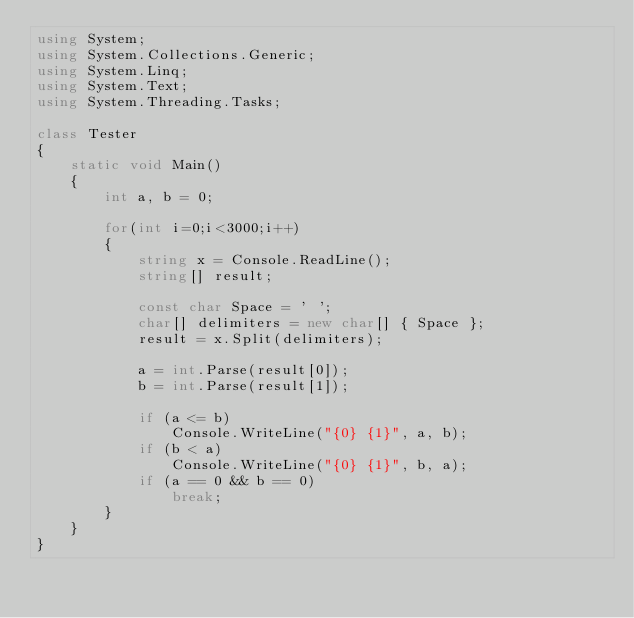Convert code to text. <code><loc_0><loc_0><loc_500><loc_500><_C#_>using System;
using System.Collections.Generic;
using System.Linq;
using System.Text;
using System.Threading.Tasks;

class Tester
{
    static void Main()
    {
        int a, b = 0;

        for(int i=0;i<3000;i++)
        {
            string x = Console.ReadLine();
            string[] result;

            const char Space = ' ';
            char[] delimiters = new char[] { Space };
            result = x.Split(delimiters);

            a = int.Parse(result[0]);
            b = int.Parse(result[1]);

            if (a <= b)
                Console.WriteLine("{0} {1}", a, b);
            if (b < a)
                Console.WriteLine("{0} {1}", b, a);
            if (a == 0 && b == 0)
                break;
        }
    }
}
</code> 